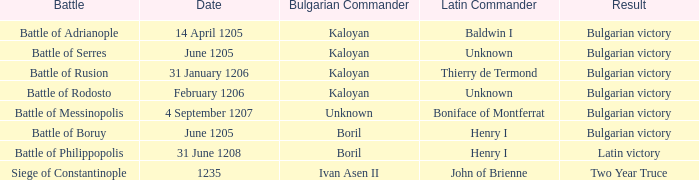Who is the Latin Commander of the Siege of Constantinople? John of Brienne. 